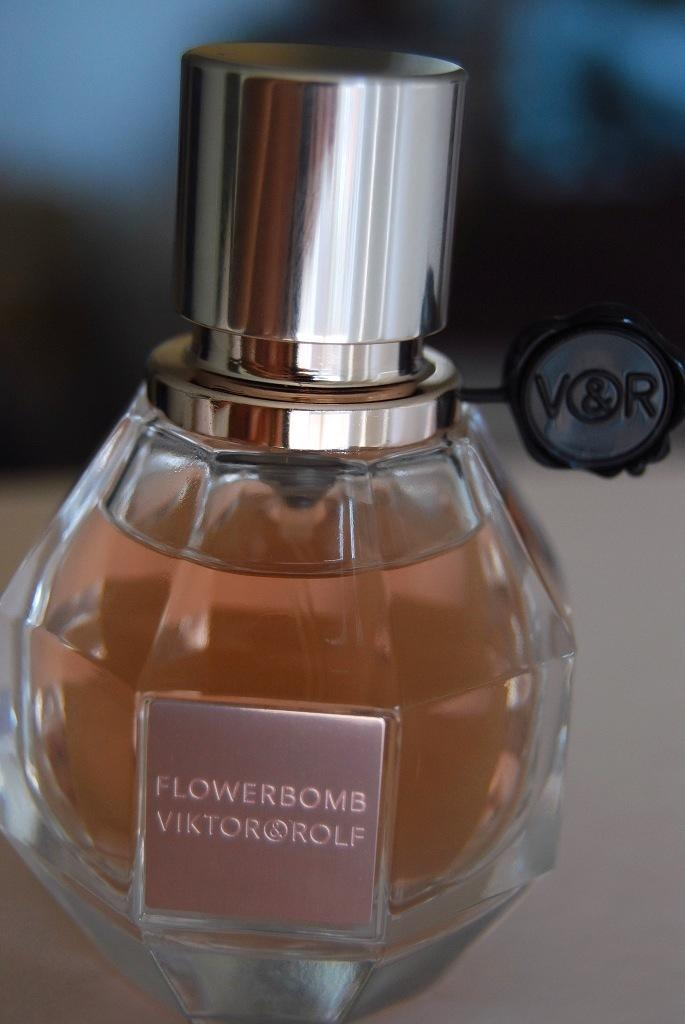<image>
Give a short and clear explanation of the subsequent image. A bottle of Flowerbomb perfume shaped like a grenade. 